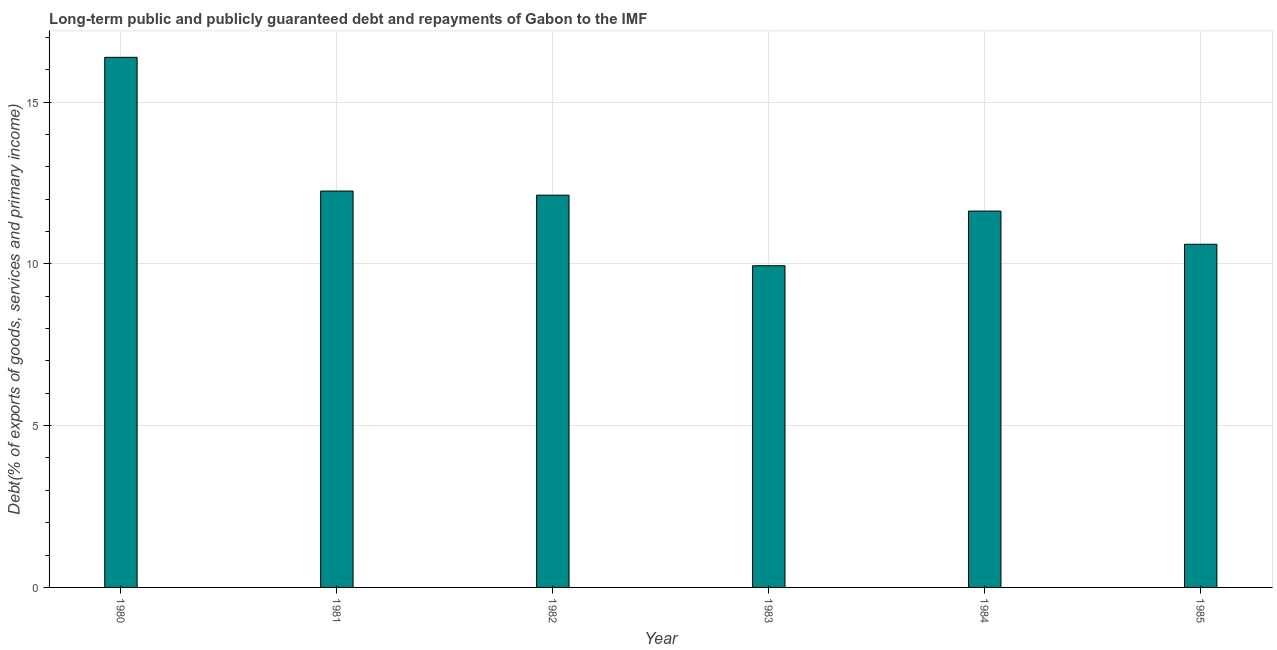Does the graph contain any zero values?
Offer a terse response. No. Does the graph contain grids?
Your answer should be very brief. Yes. What is the title of the graph?
Offer a very short reply. Long-term public and publicly guaranteed debt and repayments of Gabon to the IMF. What is the label or title of the Y-axis?
Ensure brevity in your answer.  Debt(% of exports of goods, services and primary income). What is the debt service in 1980?
Your answer should be compact. 16.38. Across all years, what is the maximum debt service?
Offer a very short reply. 16.38. Across all years, what is the minimum debt service?
Provide a short and direct response. 9.94. In which year was the debt service maximum?
Make the answer very short. 1980. What is the sum of the debt service?
Your answer should be compact. 72.92. What is the difference between the debt service in 1981 and 1982?
Your answer should be compact. 0.13. What is the average debt service per year?
Your answer should be compact. 12.15. What is the median debt service?
Provide a short and direct response. 11.88. Do a majority of the years between 1983 and 1980 (inclusive) have debt service greater than 11 %?
Your answer should be compact. Yes. What is the ratio of the debt service in 1981 to that in 1983?
Ensure brevity in your answer.  1.23. What is the difference between the highest and the second highest debt service?
Keep it short and to the point. 4.13. Is the sum of the debt service in 1980 and 1982 greater than the maximum debt service across all years?
Your response must be concise. Yes. What is the difference between the highest and the lowest debt service?
Your answer should be very brief. 6.44. In how many years, is the debt service greater than the average debt service taken over all years?
Make the answer very short. 2. How many years are there in the graph?
Offer a terse response. 6. Are the values on the major ticks of Y-axis written in scientific E-notation?
Provide a succinct answer. No. What is the Debt(% of exports of goods, services and primary income) of 1980?
Offer a terse response. 16.38. What is the Debt(% of exports of goods, services and primary income) of 1981?
Keep it short and to the point. 12.25. What is the Debt(% of exports of goods, services and primary income) in 1982?
Offer a very short reply. 12.12. What is the Debt(% of exports of goods, services and primary income) in 1983?
Make the answer very short. 9.94. What is the Debt(% of exports of goods, services and primary income) in 1984?
Ensure brevity in your answer.  11.63. What is the Debt(% of exports of goods, services and primary income) of 1985?
Offer a very short reply. 10.6. What is the difference between the Debt(% of exports of goods, services and primary income) in 1980 and 1981?
Offer a terse response. 4.13. What is the difference between the Debt(% of exports of goods, services and primary income) in 1980 and 1982?
Give a very brief answer. 4.26. What is the difference between the Debt(% of exports of goods, services and primary income) in 1980 and 1983?
Your response must be concise. 6.44. What is the difference between the Debt(% of exports of goods, services and primary income) in 1980 and 1984?
Your answer should be very brief. 4.75. What is the difference between the Debt(% of exports of goods, services and primary income) in 1980 and 1985?
Your response must be concise. 5.78. What is the difference between the Debt(% of exports of goods, services and primary income) in 1981 and 1982?
Provide a short and direct response. 0.13. What is the difference between the Debt(% of exports of goods, services and primary income) in 1981 and 1983?
Keep it short and to the point. 2.31. What is the difference between the Debt(% of exports of goods, services and primary income) in 1981 and 1984?
Ensure brevity in your answer.  0.62. What is the difference between the Debt(% of exports of goods, services and primary income) in 1981 and 1985?
Give a very brief answer. 1.64. What is the difference between the Debt(% of exports of goods, services and primary income) in 1982 and 1983?
Give a very brief answer. 2.18. What is the difference between the Debt(% of exports of goods, services and primary income) in 1982 and 1984?
Make the answer very short. 0.49. What is the difference between the Debt(% of exports of goods, services and primary income) in 1982 and 1985?
Provide a succinct answer. 1.52. What is the difference between the Debt(% of exports of goods, services and primary income) in 1983 and 1984?
Keep it short and to the point. -1.69. What is the difference between the Debt(% of exports of goods, services and primary income) in 1983 and 1985?
Offer a very short reply. -0.66. What is the difference between the Debt(% of exports of goods, services and primary income) in 1984 and 1985?
Ensure brevity in your answer.  1.03. What is the ratio of the Debt(% of exports of goods, services and primary income) in 1980 to that in 1981?
Ensure brevity in your answer.  1.34. What is the ratio of the Debt(% of exports of goods, services and primary income) in 1980 to that in 1982?
Your answer should be compact. 1.35. What is the ratio of the Debt(% of exports of goods, services and primary income) in 1980 to that in 1983?
Ensure brevity in your answer.  1.65. What is the ratio of the Debt(% of exports of goods, services and primary income) in 1980 to that in 1984?
Give a very brief answer. 1.41. What is the ratio of the Debt(% of exports of goods, services and primary income) in 1980 to that in 1985?
Your response must be concise. 1.54. What is the ratio of the Debt(% of exports of goods, services and primary income) in 1981 to that in 1982?
Keep it short and to the point. 1.01. What is the ratio of the Debt(% of exports of goods, services and primary income) in 1981 to that in 1983?
Give a very brief answer. 1.23. What is the ratio of the Debt(% of exports of goods, services and primary income) in 1981 to that in 1984?
Provide a succinct answer. 1.05. What is the ratio of the Debt(% of exports of goods, services and primary income) in 1981 to that in 1985?
Make the answer very short. 1.16. What is the ratio of the Debt(% of exports of goods, services and primary income) in 1982 to that in 1983?
Give a very brief answer. 1.22. What is the ratio of the Debt(% of exports of goods, services and primary income) in 1982 to that in 1984?
Ensure brevity in your answer.  1.04. What is the ratio of the Debt(% of exports of goods, services and primary income) in 1982 to that in 1985?
Provide a short and direct response. 1.14. What is the ratio of the Debt(% of exports of goods, services and primary income) in 1983 to that in 1984?
Provide a short and direct response. 0.85. What is the ratio of the Debt(% of exports of goods, services and primary income) in 1983 to that in 1985?
Your answer should be very brief. 0.94. What is the ratio of the Debt(% of exports of goods, services and primary income) in 1984 to that in 1985?
Your answer should be very brief. 1.1. 